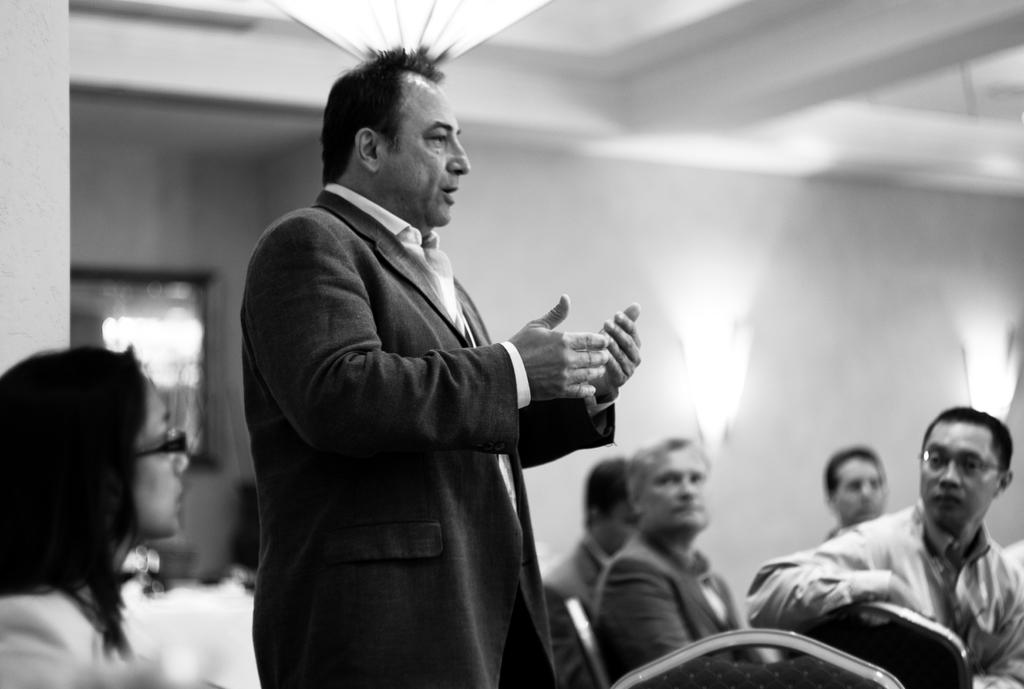What is the primary action of the person in the image? There is a person standing in the image. Can you describe the position of other individuals in the image? There are people sitting on chairs in the image. What type of bell can be heard ringing in the image? There is no bell present or ringing in the image. Can you describe the fangs of the person standing in the image? There are no fangs present on the person standing in the image. 